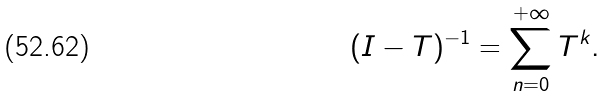<formula> <loc_0><loc_0><loc_500><loc_500>( I - T ) ^ { - 1 } = \sum _ { n = 0 } ^ { + \infty } T ^ { k } .</formula> 